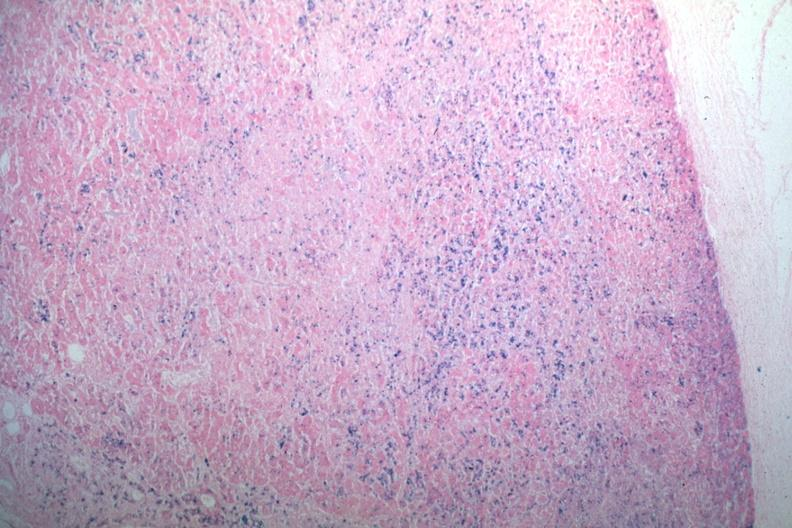does this photo of infant from head to toe stain abundant iron?
Answer the question using a single word or phrase. No 